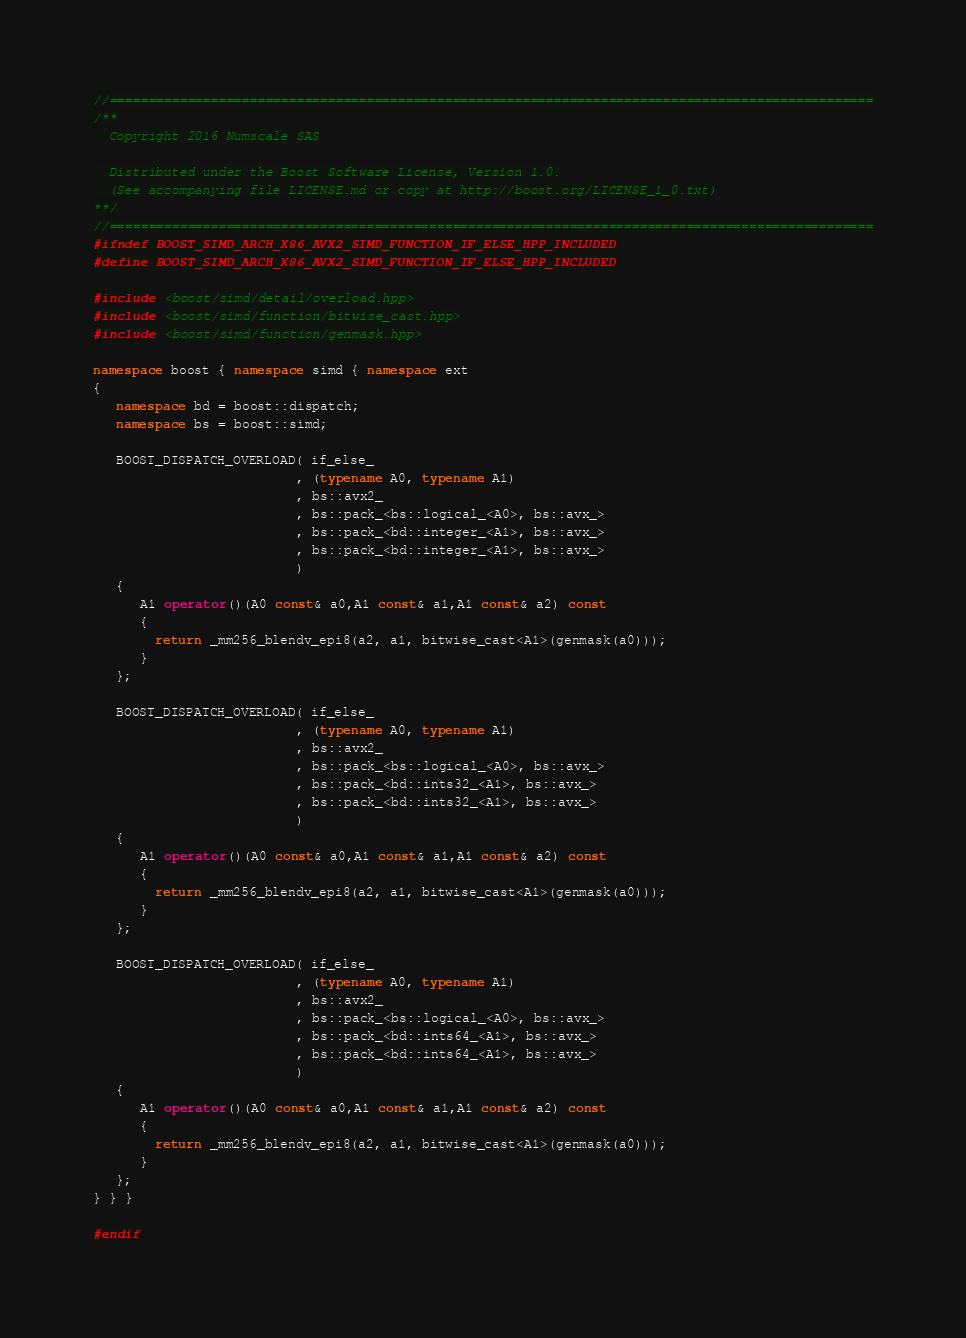<code> <loc_0><loc_0><loc_500><loc_500><_C++_>//==================================================================================================
/**
  Copyright 2016 Numscale SAS

  Distributed under the Boost Software License, Version 1.0.
  (See accompanying file LICENSE.md or copy at http://boost.org/LICENSE_1_0.txt)
**/
//==================================================================================================
#ifndef BOOST_SIMD_ARCH_X86_AVX2_SIMD_FUNCTION_IF_ELSE_HPP_INCLUDED
#define BOOST_SIMD_ARCH_X86_AVX2_SIMD_FUNCTION_IF_ELSE_HPP_INCLUDED

#include <boost/simd/detail/overload.hpp>
#include <boost/simd/function/bitwise_cast.hpp>
#include <boost/simd/function/genmask.hpp>

namespace boost { namespace simd { namespace ext
{
   namespace bd = boost::dispatch;
   namespace bs = boost::simd;

   BOOST_DISPATCH_OVERLOAD( if_else_
                          , (typename A0, typename A1)
                          , bs::avx2_
                          , bs::pack_<bs::logical_<A0>, bs::avx_>
                          , bs::pack_<bd::integer_<A1>, bs::avx_>
                          , bs::pack_<bd::integer_<A1>, bs::avx_>
                          )
   {
      A1 operator()(A0 const& a0,A1 const& a1,A1 const& a2) const
      {
        return _mm256_blendv_epi8(a2, a1, bitwise_cast<A1>(genmask(a0)));
      }
   };

   BOOST_DISPATCH_OVERLOAD( if_else_
                          , (typename A0, typename A1)
                          , bs::avx2_
                          , bs::pack_<bs::logical_<A0>, bs::avx_>
                          , bs::pack_<bd::ints32_<A1>, bs::avx_>
                          , bs::pack_<bd::ints32_<A1>, bs::avx_>
                          )
   {
      A1 operator()(A0 const& a0,A1 const& a1,A1 const& a2) const
      {
        return _mm256_blendv_epi8(a2, a1, bitwise_cast<A1>(genmask(a0)));
      }
   };

   BOOST_DISPATCH_OVERLOAD( if_else_
                          , (typename A0, typename A1)
                          , bs::avx2_
                          , bs::pack_<bs::logical_<A0>, bs::avx_>
                          , bs::pack_<bd::ints64_<A1>, bs::avx_>
                          , bs::pack_<bd::ints64_<A1>, bs::avx_>
                          )
   {
      A1 operator()(A0 const& a0,A1 const& a1,A1 const& a2) const
      {
        return _mm256_blendv_epi8(a2, a1, bitwise_cast<A1>(genmask(a0)));
      }
   };
} } }

#endif
</code> 